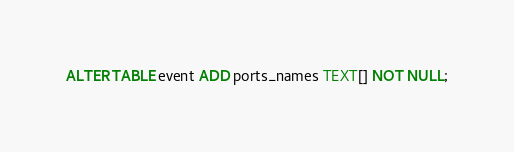Convert code to text. <code><loc_0><loc_0><loc_500><loc_500><_SQL_>ALTER TABLE event ADD ports_names TEXT[] NOT NULL;</code> 